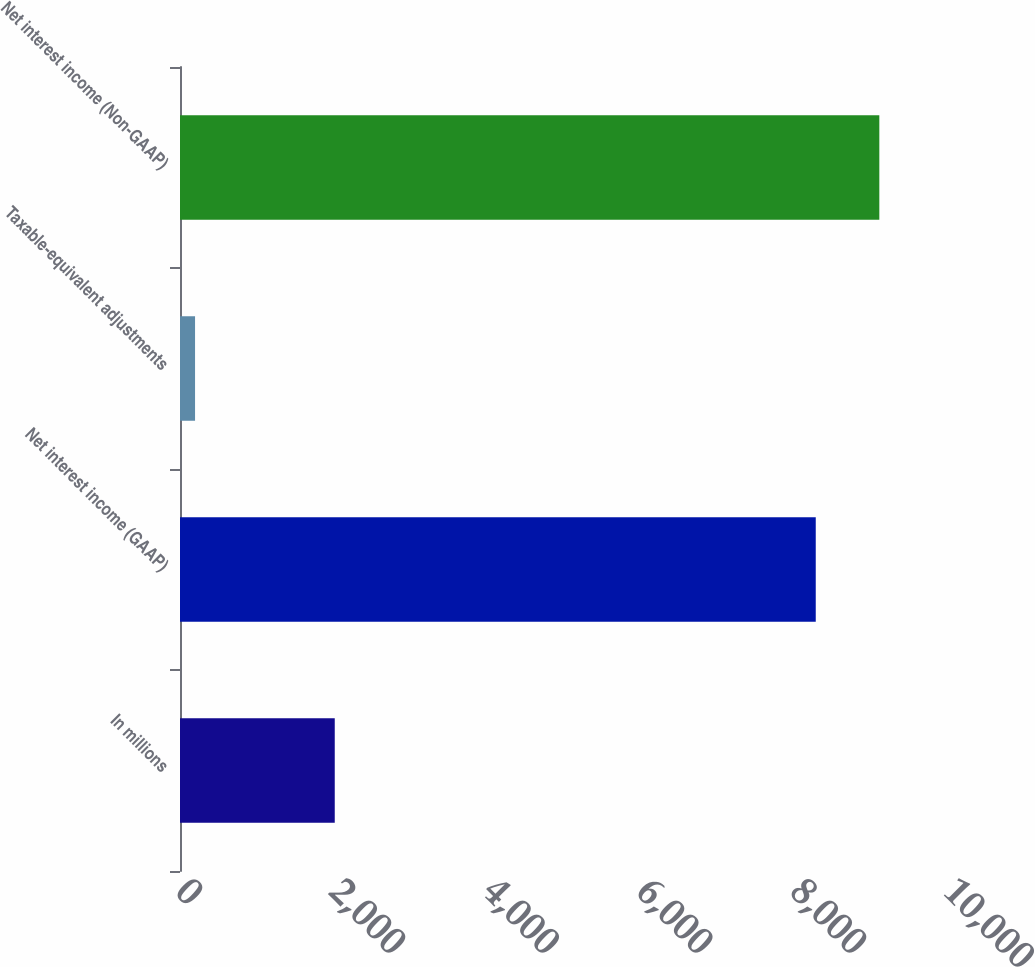<chart> <loc_0><loc_0><loc_500><loc_500><bar_chart><fcel>In millions<fcel>Net interest income (GAAP)<fcel>Taxable-equivalent adjustments<fcel>Net interest income (Non-GAAP)<nl><fcel>2015<fcel>8278<fcel>196<fcel>9105.8<nl></chart> 